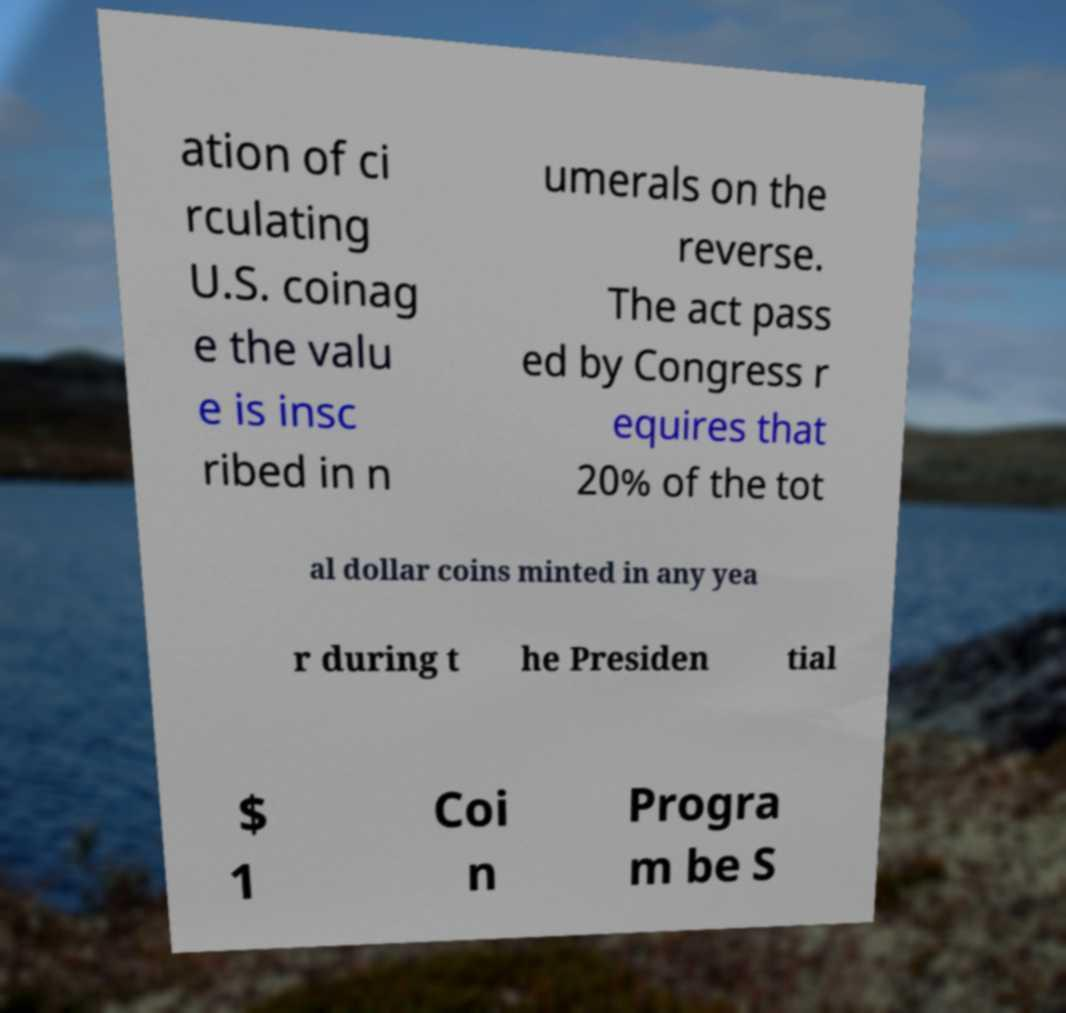Could you extract and type out the text from this image? ation of ci rculating U.S. coinag e the valu e is insc ribed in n umerals on the reverse. The act pass ed by Congress r equires that 20% of the tot al dollar coins minted in any yea r during t he Presiden tial $ 1 Coi n Progra m be S 